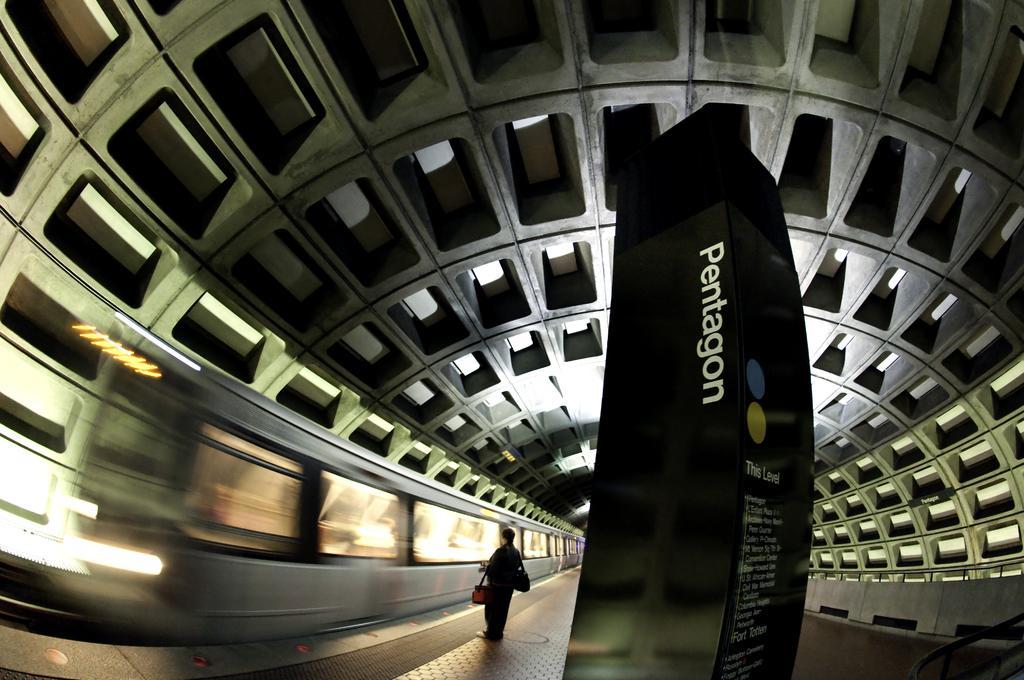In one or two sentences, can you explain what this image depicts? In the middle of the picture, we see a board or a pillar in black color with some text written on it. Beside that, we see a man who is wearing the bags are standing. In front of him, we see the televisions. At the top, we see the ceiling. 